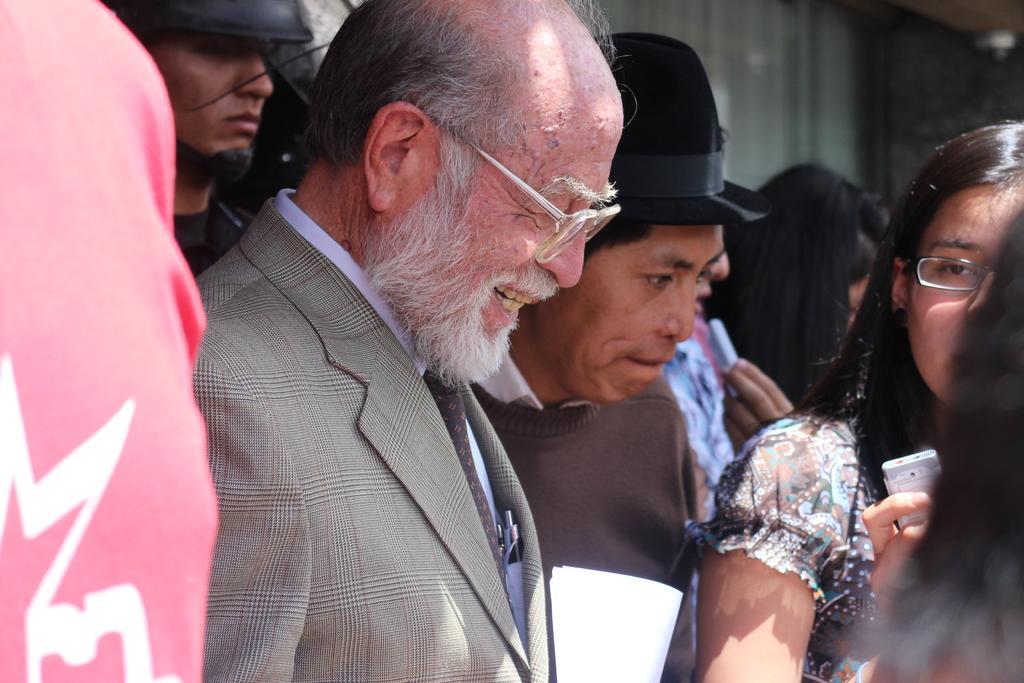Can you describe this image briefly? In the image a group of people were gathered in a place and in between them there is a man and he is smiling, the background is blurry. 